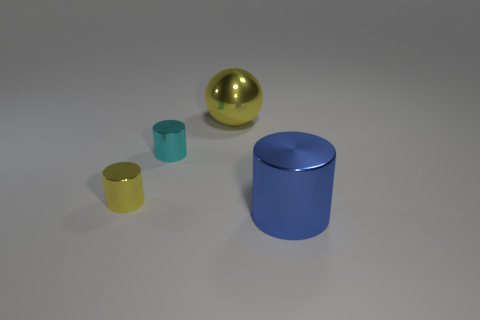If this were a physics experiment, what concept might it demonstrate? If this image were representing a physics experiment, it might demonstrate concepts such as geometry, symmetry, or reflections due to the different shapes and reflective surfaces of the objects. Other possible concepts could include center of gravity and balance, especially if the objects were positioned to show stability or instability. 